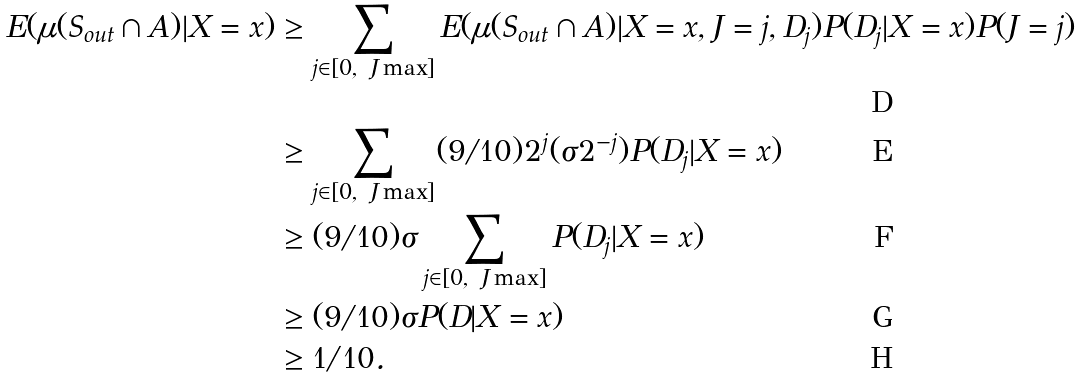Convert formula to latex. <formula><loc_0><loc_0><loc_500><loc_500>E ( \mu ( S _ { o u t } \cap A ) | X = x ) & \geq \sum _ { j \in [ 0 , \ J \max ] } E ( \mu ( S _ { o u t } \cap A ) | X = x , J = j , D _ { j } ) P ( D _ { j } | X = x ) P ( J = j ) \\ & \geq \sum _ { j \in [ 0 , \ J \max ] } ( 9 / 1 0 ) 2 ^ { j } ( \sigma 2 ^ { - j } ) P ( D _ { j } | X = x ) \\ & \geq ( 9 / 1 0 ) \sigma \sum _ { j \in [ 0 , \ J \max ] } P ( D _ { j } | X = x ) \\ & \geq ( 9 / 1 0 ) \sigma P ( D | X = x ) \\ & \geq 1 / 1 0 .</formula> 